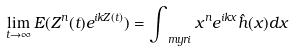<formula> <loc_0><loc_0><loc_500><loc_500>\lim _ { t \rightarrow \infty } E ( Z ^ { n } ( t ) e ^ { i k Z ( t ) } ) = \int _ { \ m y r i } x ^ { n } e ^ { i k x } \hat { h } ( x ) d x</formula> 